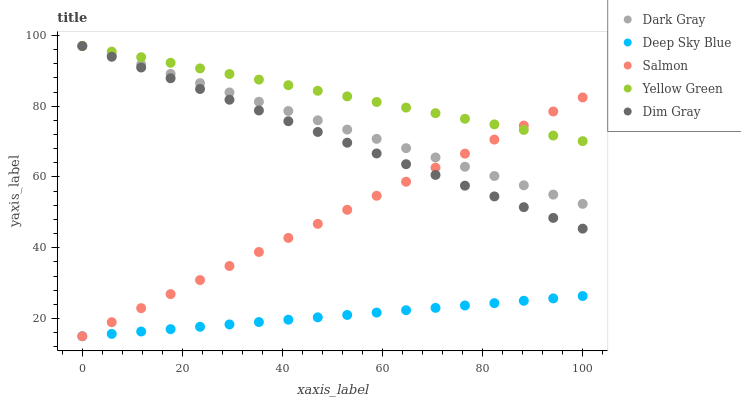Does Deep Sky Blue have the minimum area under the curve?
Answer yes or no. Yes. Does Yellow Green have the maximum area under the curve?
Answer yes or no. Yes. Does Dim Gray have the minimum area under the curve?
Answer yes or no. No. Does Dim Gray have the maximum area under the curve?
Answer yes or no. No. Is Dim Gray the smoothest?
Answer yes or no. Yes. Is Salmon the roughest?
Answer yes or no. Yes. Is Salmon the smoothest?
Answer yes or no. No. Is Dim Gray the roughest?
Answer yes or no. No. Does Salmon have the lowest value?
Answer yes or no. Yes. Does Dim Gray have the lowest value?
Answer yes or no. No. Does Yellow Green have the highest value?
Answer yes or no. Yes. Does Salmon have the highest value?
Answer yes or no. No. Is Deep Sky Blue less than Yellow Green?
Answer yes or no. Yes. Is Dim Gray greater than Deep Sky Blue?
Answer yes or no. Yes. Does Salmon intersect Dim Gray?
Answer yes or no. Yes. Is Salmon less than Dim Gray?
Answer yes or no. No. Is Salmon greater than Dim Gray?
Answer yes or no. No. Does Deep Sky Blue intersect Yellow Green?
Answer yes or no. No. 